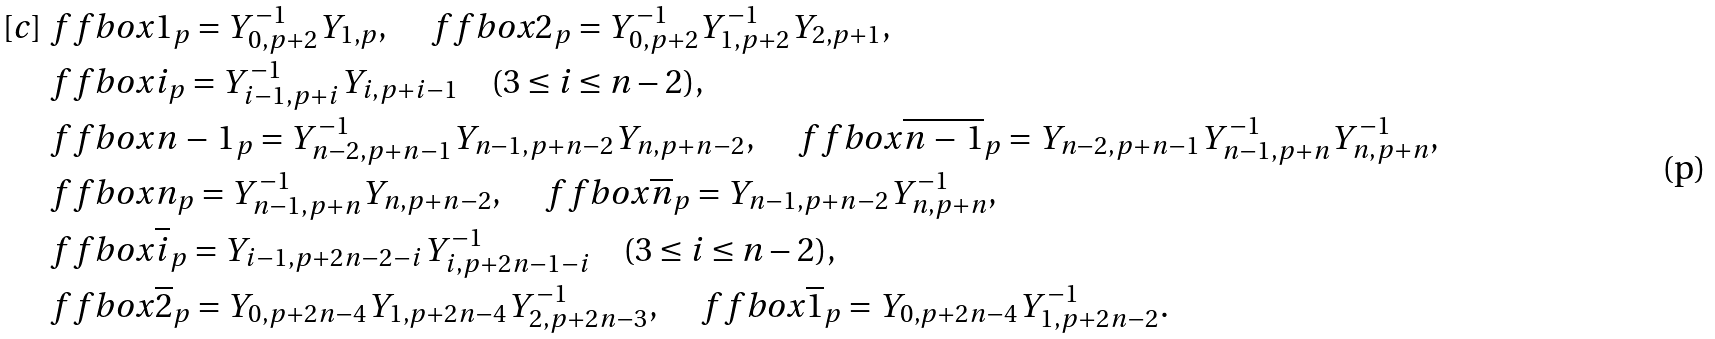Convert formula to latex. <formula><loc_0><loc_0><loc_500><loc_500>[ c ] & \ f f b o x { 1 } _ { p } = Y _ { 0 , p + 2 } ^ { - 1 } Y _ { 1 , p } , \quad \ f f b o x { 2 } _ { p } = Y _ { 0 , p + 2 } ^ { - 1 } Y _ { 1 , p + 2 } ^ { - 1 } Y _ { 2 , p + 1 } , \\ & \ f f b o x { i } _ { p } = Y _ { i - 1 , p + i } ^ { - 1 } Y _ { i , p + { i - 1 } } \quad ( 3 \leq i \leq n - 2 ) , \\ & \ f f b o x { n \, - \, 1 } _ { p } = Y _ { n - 2 , p + { n - 1 } } ^ { - 1 } Y _ { n - 1 , p + { n - 2 } } Y _ { n , p + { n - 2 } } , \quad \ f f b o x { \overline { n \, - \, 1 } } _ { p } = Y _ { n - 2 , p + { n - 1 } } Y _ { n - 1 , p + { n } } ^ { - 1 } Y _ { n , p + { n } } ^ { - 1 } , \\ & \ f f b o x { n } _ { p } = Y _ { n - 1 , p + { n } } ^ { - 1 } Y _ { n , p + { n - 2 } } , \quad \ f f b o x { \overline { n } } _ { p } = Y _ { n - 1 , p + { n - 2 } } Y _ { n , p + { n } } ^ { - 1 } , \\ & \ f f b o x { \overline { i } } _ { p } = Y _ { i - 1 , p + { 2 n - 2 - i } } Y _ { i , p + { 2 n - 1 - i } } ^ { - 1 } \quad ( 3 \leq i \leq n - 2 ) , \\ & \ f f b o x { \overline { 2 } } _ { p } = Y _ { 0 , p + 2 n - 4 } Y _ { 1 , p + 2 n - 4 } Y _ { 2 , p + 2 n - 3 } ^ { - 1 } , \quad \ f f b o x { \overline { 1 } } _ { p } = Y _ { 0 , p + 2 n - 4 } Y _ { 1 , p + { 2 n - 2 } } ^ { - 1 } .</formula> 